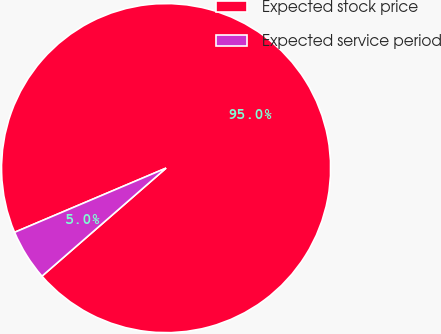Convert chart to OTSL. <chart><loc_0><loc_0><loc_500><loc_500><pie_chart><fcel>Expected stock price<fcel>Expected service period<nl><fcel>94.98%<fcel>5.02%<nl></chart> 